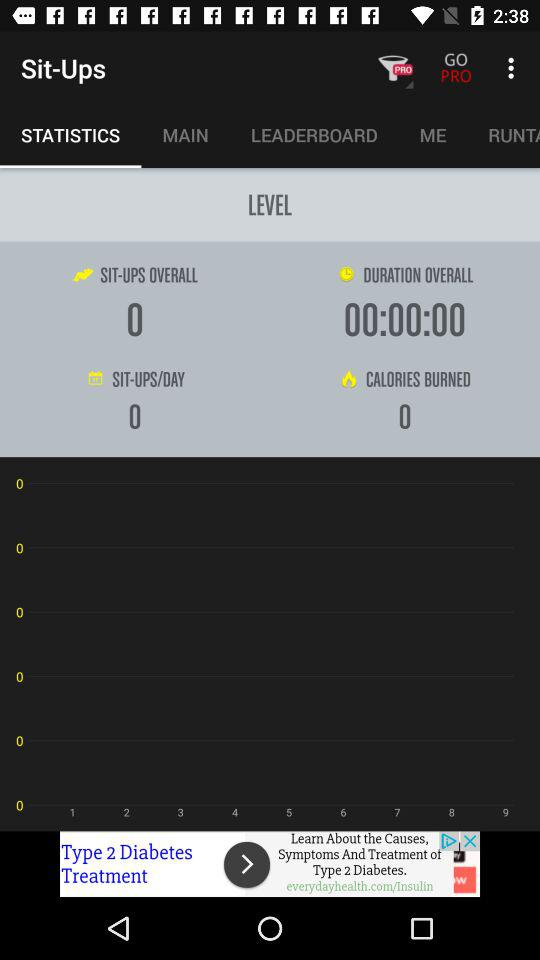Which option is selected in "Sit-Ups"? The selected option is "STATISTICS". 